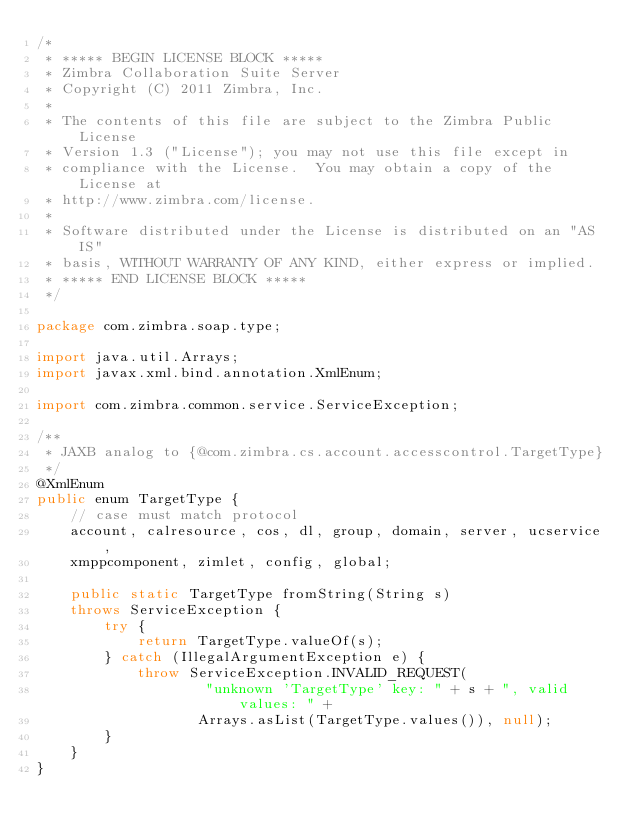<code> <loc_0><loc_0><loc_500><loc_500><_Java_>/*
 * ***** BEGIN LICENSE BLOCK *****
 * Zimbra Collaboration Suite Server
 * Copyright (C) 2011 Zimbra, Inc.
 *
 * The contents of this file are subject to the Zimbra Public License
 * Version 1.3 ("License"); you may not use this file except in
 * compliance with the License.  You may obtain a copy of the License at
 * http://www.zimbra.com/license.
 *
 * Software distributed under the License is distributed on an "AS IS"
 * basis, WITHOUT WARRANTY OF ANY KIND, either express or implied.
 * ***** END LICENSE BLOCK *****
 */

package com.zimbra.soap.type;

import java.util.Arrays;
import javax.xml.bind.annotation.XmlEnum;

import com.zimbra.common.service.ServiceException;

/**
 * JAXB analog to {@com.zimbra.cs.account.accesscontrol.TargetType}
 */
@XmlEnum
public enum TargetType {
    // case must match protocol
    account, calresource, cos, dl, group, domain, server, ucservice,
    xmppcomponent, zimlet, config, global;

    public static TargetType fromString(String s)
    throws ServiceException {
        try {
            return TargetType.valueOf(s);
        } catch (IllegalArgumentException e) {
            throw ServiceException.INVALID_REQUEST(
                    "unknown 'TargetType' key: " + s + ", valid values: " +
                   Arrays.asList(TargetType.values()), null);
        }
    }
}
</code> 